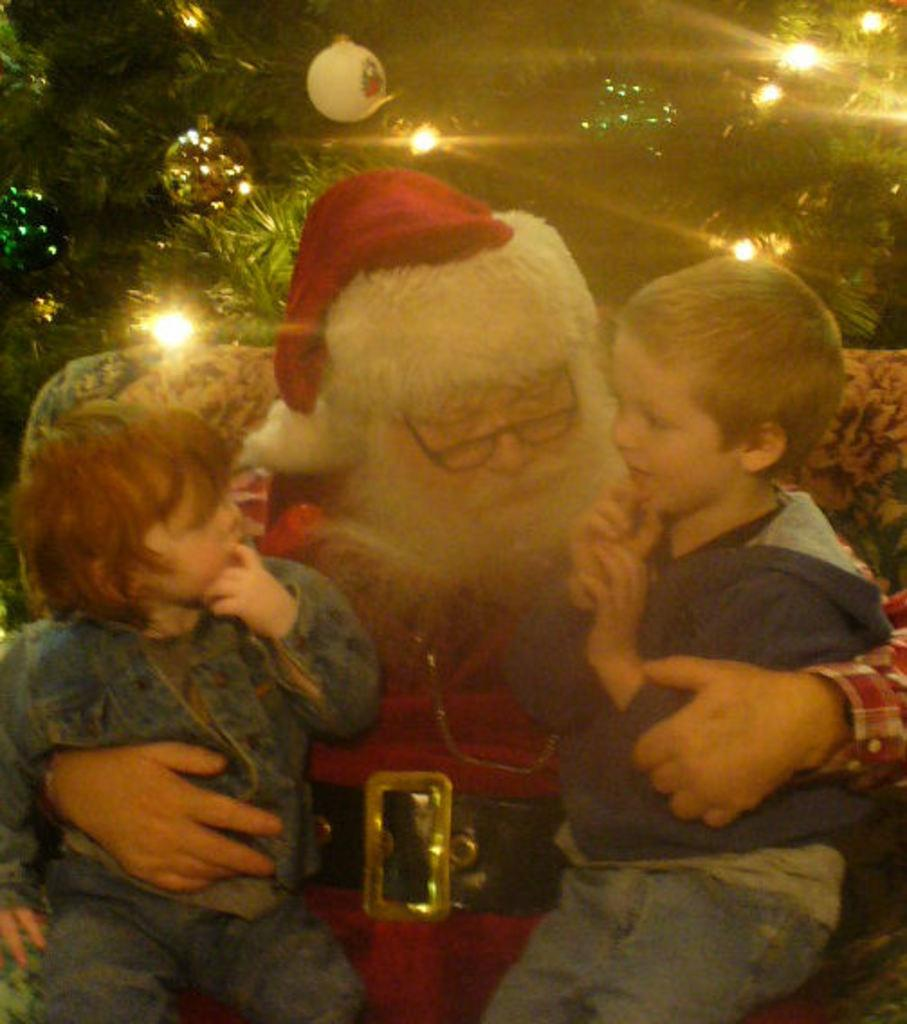Who is the main subject in the image? There is a man in the image. What is the man doing in the image? The man is holding two children in his arms. What type of machine is being used by the man in the image? There is no machine present in the image; the man is holding two children in his arms. What kind of lumber is visible in the image? There is no lumber present in the image; the man is holding two children in his arms. 